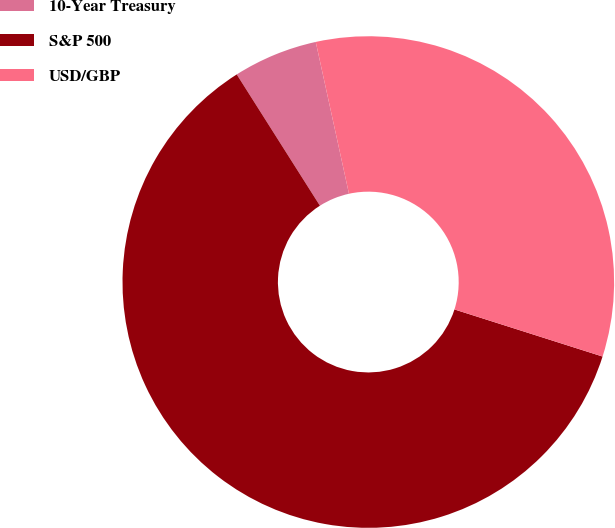Convert chart. <chart><loc_0><loc_0><loc_500><loc_500><pie_chart><fcel>10-Year Treasury<fcel>S&P 500<fcel>USD/GBP<nl><fcel>5.56%<fcel>61.11%<fcel>33.33%<nl></chart> 